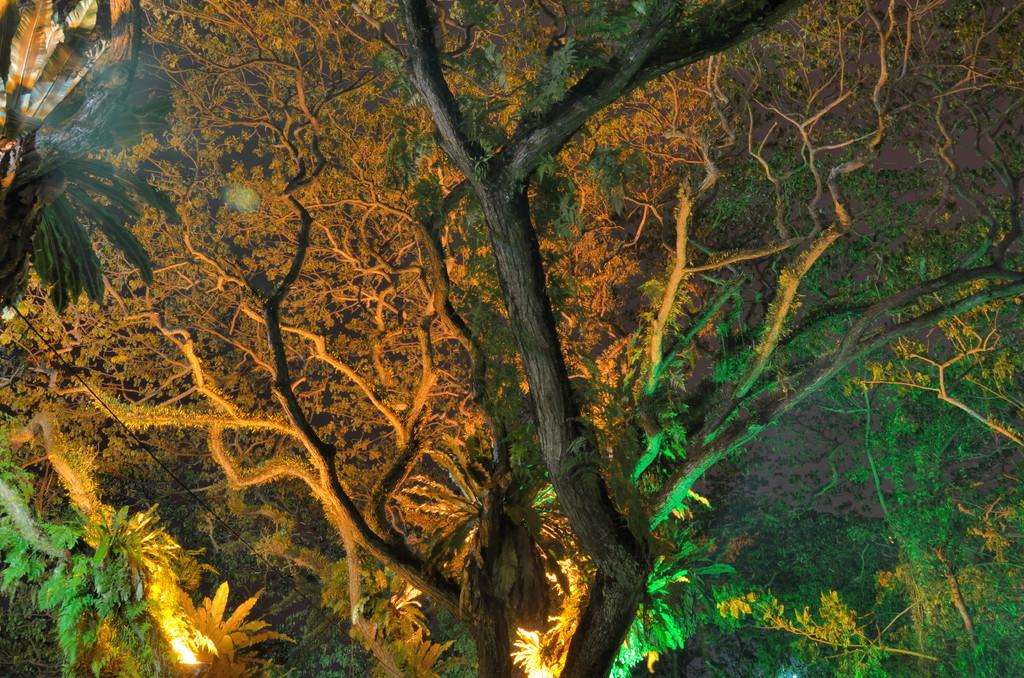What is the primary feature of the image? The primary feature of the image is the presence of many trees. Are there any additional elements added to the trees? Yes, there are lights on the trees. How does the coastline affect the growth of the trees in the image? The image does not show a coastline, so it is not possible to determine the effect of a coastline on the growth of the trees. 